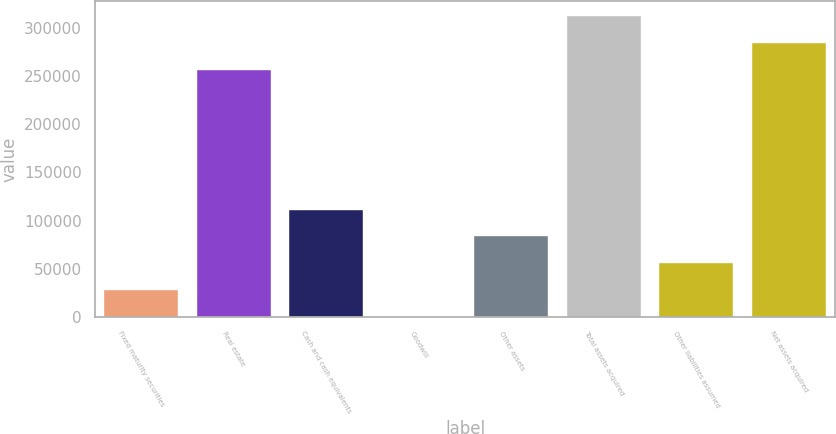Convert chart to OTSL. <chart><loc_0><loc_0><loc_500><loc_500><bar_chart><fcel>Fixed maturity securities<fcel>Real estate<fcel>Cash and cash equivalents<fcel>Goodwill<fcel>Other assets<fcel>Total assets acquired<fcel>Other liabilities assumed<fcel>Net assets acquired<nl><fcel>28067<fcel>256209<fcel>111515<fcel>251<fcel>83699<fcel>311841<fcel>55883<fcel>284025<nl></chart> 